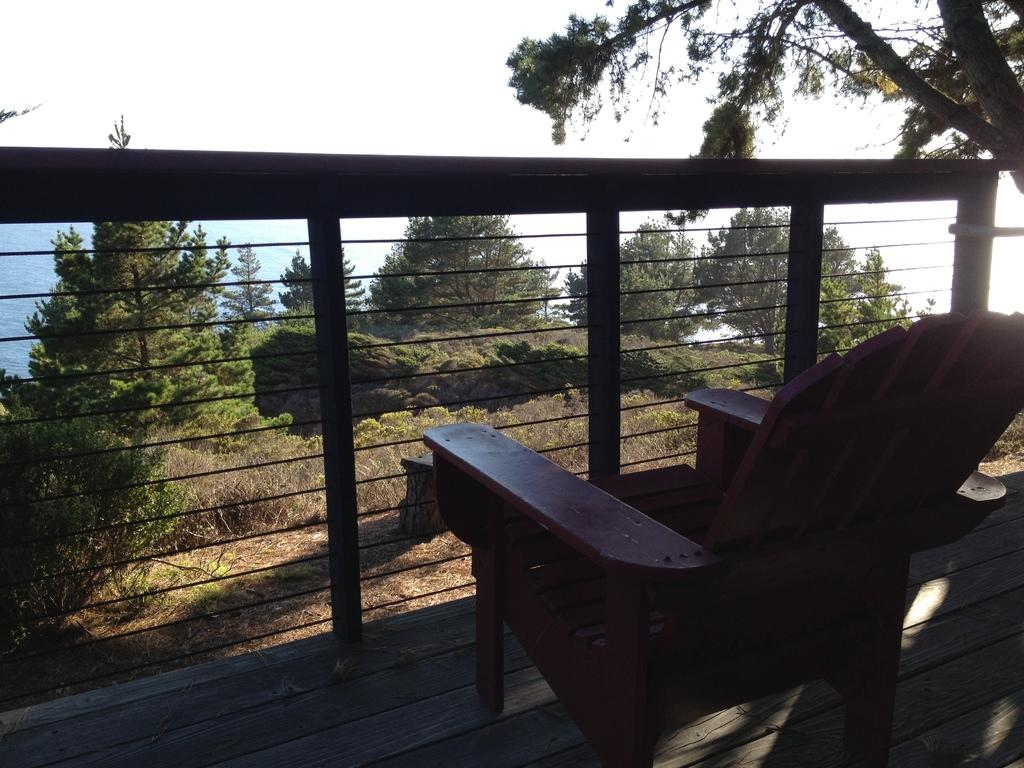What type of furniture is on the wooden platform in the image? There is a chair on a wooden platform in the image. What type of barrier can be seen in the image? There is a fence in the image. What type of vegetation is present in the image? Trees, grass, and plants are present in the image. What can be seen in the background of the image? Water and the sky are visible in the background of the image. How many sisters are sitting on the chair in the image? There are no sisters present in the image; only a chair is visible on the wooden platform. What is the limit of the water visible in the background of the image? The image does not provide information about the limit or extent of the water visible in the background. 